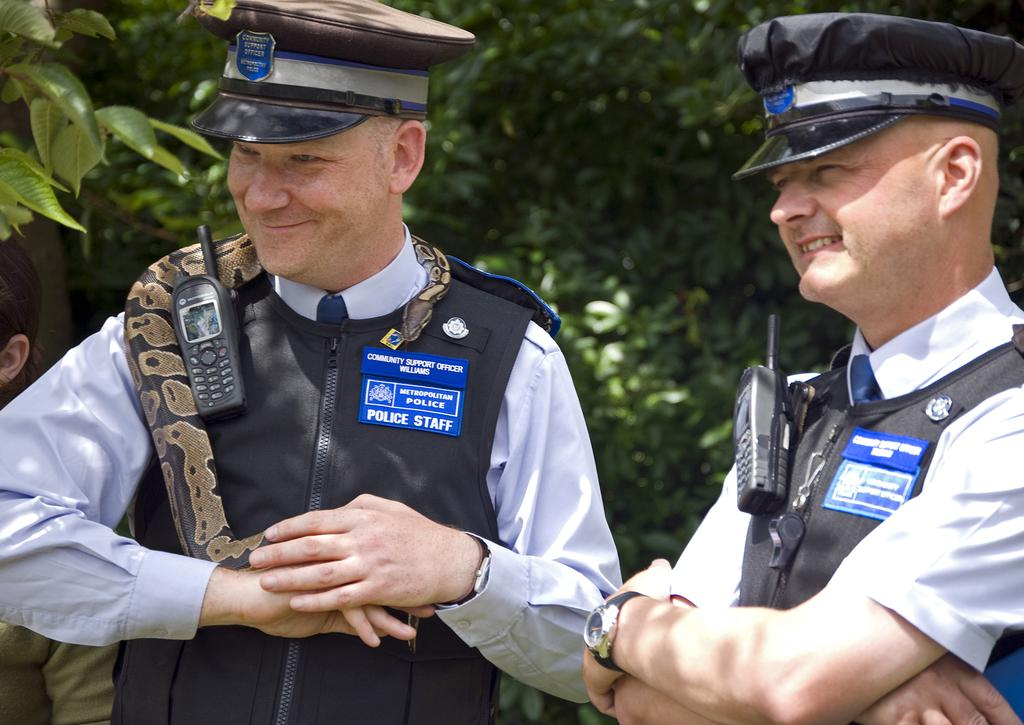<image>
Share a concise interpretation of the image provided. Two men are wearing blue metropolitan police badges. 